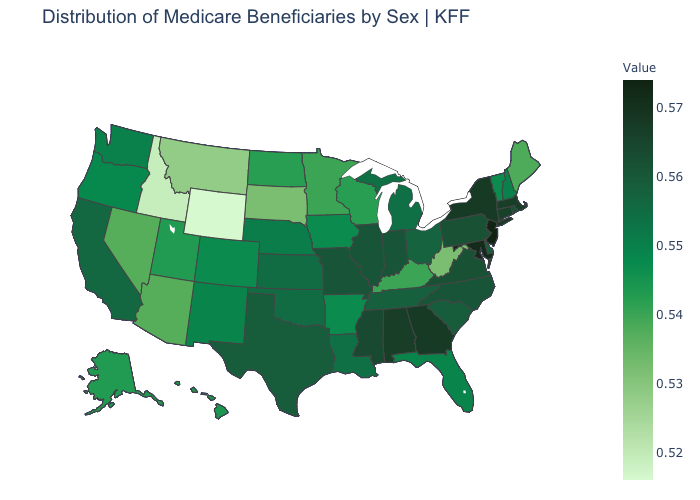Which states have the lowest value in the West?
Answer briefly. Wyoming. Does the map have missing data?
Short answer required. No. Is the legend a continuous bar?
Give a very brief answer. Yes. Which states have the highest value in the USA?
Keep it brief. New Jersey. Which states have the highest value in the USA?
Be succinct. New Jersey. Among the states that border Georgia , does Florida have the lowest value?
Write a very short answer. Yes. Among the states that border Georgia , which have the highest value?
Keep it brief. Alabama. 